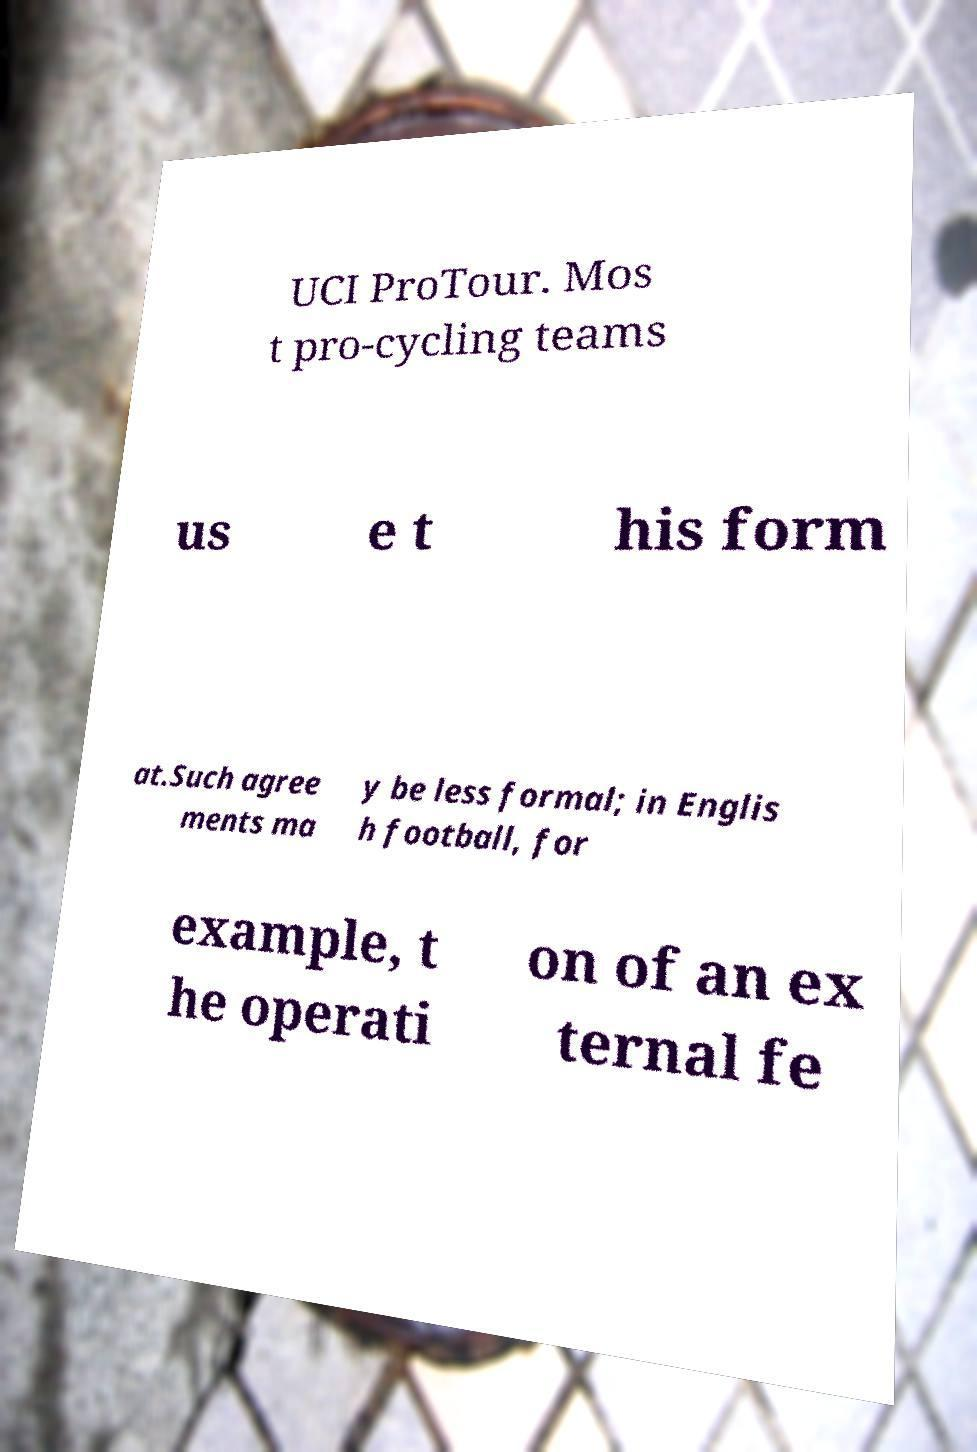Could you assist in decoding the text presented in this image and type it out clearly? UCI ProTour. Mos t pro-cycling teams us e t his form at.Such agree ments ma y be less formal; in Englis h football, for example, t he operati on of an ex ternal fe 